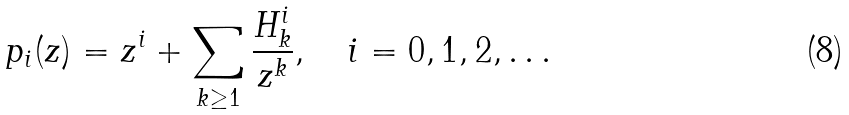<formula> <loc_0><loc_0><loc_500><loc_500>p _ { i } ( z ) = z ^ { i } + \sum _ { k \geq 1 } \frac { H ^ { i } _ { k } } { z ^ { k } } , \quad i = 0 , 1 , 2 , \dots</formula> 